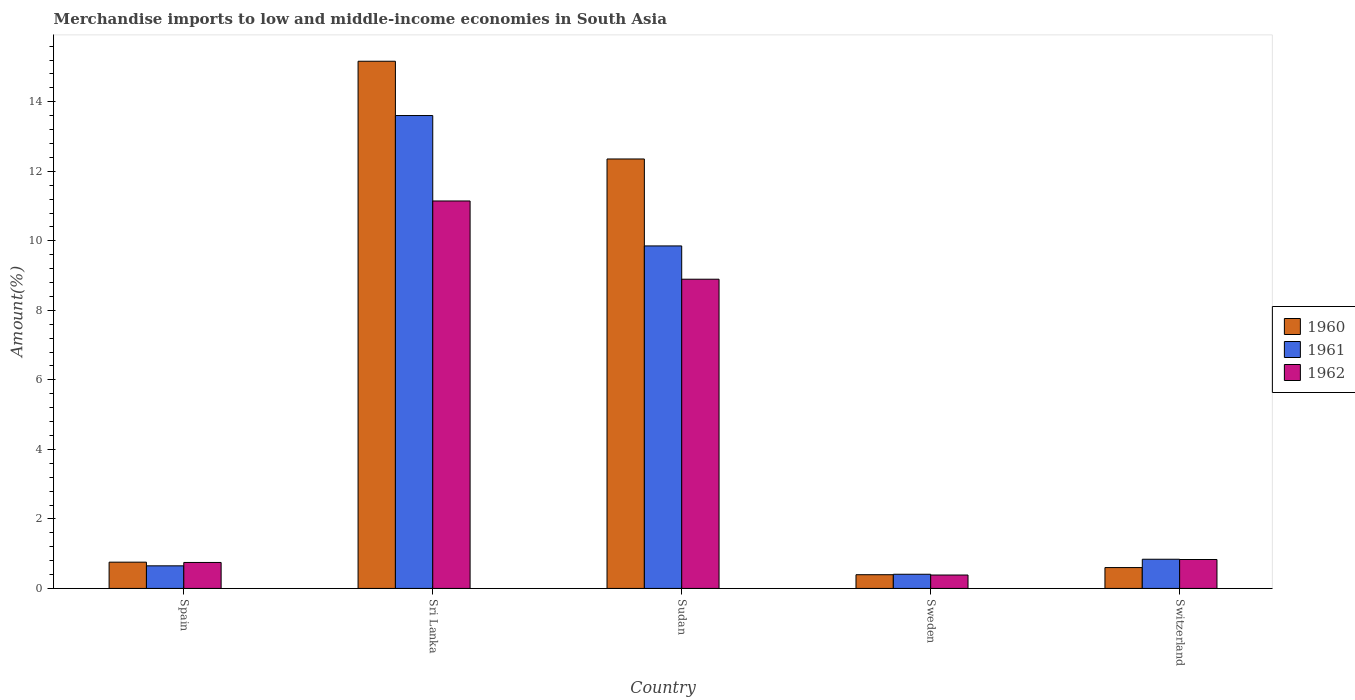How many different coloured bars are there?
Ensure brevity in your answer.  3. How many groups of bars are there?
Your response must be concise. 5. Are the number of bars on each tick of the X-axis equal?
Provide a short and direct response. Yes. How many bars are there on the 1st tick from the left?
Keep it short and to the point. 3. How many bars are there on the 4th tick from the right?
Provide a short and direct response. 3. What is the label of the 2nd group of bars from the left?
Your answer should be very brief. Sri Lanka. What is the percentage of amount earned from merchandise imports in 1962 in Spain?
Give a very brief answer. 0.75. Across all countries, what is the maximum percentage of amount earned from merchandise imports in 1962?
Offer a very short reply. 11.15. Across all countries, what is the minimum percentage of amount earned from merchandise imports in 1961?
Ensure brevity in your answer.  0.41. In which country was the percentage of amount earned from merchandise imports in 1961 maximum?
Your answer should be very brief. Sri Lanka. What is the total percentage of amount earned from merchandise imports in 1961 in the graph?
Offer a very short reply. 25.36. What is the difference between the percentage of amount earned from merchandise imports in 1961 in Sri Lanka and that in Sweden?
Offer a very short reply. 13.2. What is the difference between the percentage of amount earned from merchandise imports in 1960 in Spain and the percentage of amount earned from merchandise imports in 1962 in Sri Lanka?
Keep it short and to the point. -10.39. What is the average percentage of amount earned from merchandise imports in 1962 per country?
Ensure brevity in your answer.  4.4. What is the difference between the percentage of amount earned from merchandise imports of/in 1961 and percentage of amount earned from merchandise imports of/in 1960 in Sudan?
Provide a succinct answer. -2.5. What is the ratio of the percentage of amount earned from merchandise imports in 1962 in Spain to that in Switzerland?
Your answer should be very brief. 0.9. Is the percentage of amount earned from merchandise imports in 1961 in Spain less than that in Sudan?
Offer a very short reply. Yes. What is the difference between the highest and the second highest percentage of amount earned from merchandise imports in 1962?
Offer a very short reply. 8.06. What is the difference between the highest and the lowest percentage of amount earned from merchandise imports in 1961?
Your response must be concise. 13.2. In how many countries, is the percentage of amount earned from merchandise imports in 1961 greater than the average percentage of amount earned from merchandise imports in 1961 taken over all countries?
Your response must be concise. 2. Is the sum of the percentage of amount earned from merchandise imports in 1962 in Sudan and Sweden greater than the maximum percentage of amount earned from merchandise imports in 1960 across all countries?
Your response must be concise. No. What does the 2nd bar from the left in Sri Lanka represents?
Offer a very short reply. 1961. What does the 1st bar from the right in Sudan represents?
Make the answer very short. 1962. How many bars are there?
Make the answer very short. 15. Are the values on the major ticks of Y-axis written in scientific E-notation?
Provide a short and direct response. No. Does the graph contain any zero values?
Provide a succinct answer. No. Where does the legend appear in the graph?
Offer a very short reply. Center right. How many legend labels are there?
Your response must be concise. 3. How are the legend labels stacked?
Ensure brevity in your answer.  Vertical. What is the title of the graph?
Offer a very short reply. Merchandise imports to low and middle-income economies in South Asia. Does "2008" appear as one of the legend labels in the graph?
Provide a succinct answer. No. What is the label or title of the Y-axis?
Offer a terse response. Amount(%). What is the Amount(%) in 1960 in Spain?
Provide a short and direct response. 0.76. What is the Amount(%) in 1961 in Spain?
Provide a short and direct response. 0.65. What is the Amount(%) of 1962 in Spain?
Make the answer very short. 0.75. What is the Amount(%) of 1960 in Sri Lanka?
Offer a terse response. 15.17. What is the Amount(%) of 1961 in Sri Lanka?
Your response must be concise. 13.6. What is the Amount(%) of 1962 in Sri Lanka?
Ensure brevity in your answer.  11.15. What is the Amount(%) in 1960 in Sudan?
Give a very brief answer. 12.35. What is the Amount(%) in 1961 in Sudan?
Offer a very short reply. 9.85. What is the Amount(%) in 1962 in Sudan?
Your answer should be compact. 8.9. What is the Amount(%) in 1960 in Sweden?
Offer a very short reply. 0.39. What is the Amount(%) of 1961 in Sweden?
Offer a very short reply. 0.41. What is the Amount(%) in 1962 in Sweden?
Offer a terse response. 0.39. What is the Amount(%) of 1960 in Switzerland?
Your response must be concise. 0.6. What is the Amount(%) in 1961 in Switzerland?
Provide a short and direct response. 0.84. What is the Amount(%) of 1962 in Switzerland?
Provide a succinct answer. 0.83. Across all countries, what is the maximum Amount(%) in 1960?
Your response must be concise. 15.17. Across all countries, what is the maximum Amount(%) of 1961?
Ensure brevity in your answer.  13.6. Across all countries, what is the maximum Amount(%) of 1962?
Offer a very short reply. 11.15. Across all countries, what is the minimum Amount(%) of 1960?
Keep it short and to the point. 0.39. Across all countries, what is the minimum Amount(%) in 1961?
Provide a short and direct response. 0.41. Across all countries, what is the minimum Amount(%) in 1962?
Keep it short and to the point. 0.39. What is the total Amount(%) of 1960 in the graph?
Provide a succinct answer. 29.27. What is the total Amount(%) of 1961 in the graph?
Offer a terse response. 25.36. What is the total Amount(%) of 1962 in the graph?
Give a very brief answer. 22.01. What is the difference between the Amount(%) in 1960 in Spain and that in Sri Lanka?
Offer a terse response. -14.41. What is the difference between the Amount(%) of 1961 in Spain and that in Sri Lanka?
Your response must be concise. -12.95. What is the difference between the Amount(%) of 1962 in Spain and that in Sri Lanka?
Offer a terse response. -10.4. What is the difference between the Amount(%) in 1960 in Spain and that in Sudan?
Provide a short and direct response. -11.6. What is the difference between the Amount(%) of 1961 in Spain and that in Sudan?
Give a very brief answer. -9.2. What is the difference between the Amount(%) in 1962 in Spain and that in Sudan?
Provide a succinct answer. -8.15. What is the difference between the Amount(%) in 1960 in Spain and that in Sweden?
Your response must be concise. 0.36. What is the difference between the Amount(%) of 1961 in Spain and that in Sweden?
Provide a succinct answer. 0.24. What is the difference between the Amount(%) of 1962 in Spain and that in Sweden?
Make the answer very short. 0.36. What is the difference between the Amount(%) of 1960 in Spain and that in Switzerland?
Ensure brevity in your answer.  0.16. What is the difference between the Amount(%) in 1961 in Spain and that in Switzerland?
Your response must be concise. -0.19. What is the difference between the Amount(%) in 1962 in Spain and that in Switzerland?
Provide a short and direct response. -0.09. What is the difference between the Amount(%) of 1960 in Sri Lanka and that in Sudan?
Give a very brief answer. 2.81. What is the difference between the Amount(%) in 1961 in Sri Lanka and that in Sudan?
Keep it short and to the point. 3.75. What is the difference between the Amount(%) in 1962 in Sri Lanka and that in Sudan?
Your response must be concise. 2.25. What is the difference between the Amount(%) in 1960 in Sri Lanka and that in Sweden?
Offer a very short reply. 14.77. What is the difference between the Amount(%) in 1961 in Sri Lanka and that in Sweden?
Offer a terse response. 13.2. What is the difference between the Amount(%) in 1962 in Sri Lanka and that in Sweden?
Your response must be concise. 10.76. What is the difference between the Amount(%) in 1960 in Sri Lanka and that in Switzerland?
Your response must be concise. 14.57. What is the difference between the Amount(%) in 1961 in Sri Lanka and that in Switzerland?
Make the answer very short. 12.76. What is the difference between the Amount(%) in 1962 in Sri Lanka and that in Switzerland?
Offer a very short reply. 10.31. What is the difference between the Amount(%) of 1960 in Sudan and that in Sweden?
Provide a short and direct response. 11.96. What is the difference between the Amount(%) of 1961 in Sudan and that in Sweden?
Ensure brevity in your answer.  9.45. What is the difference between the Amount(%) of 1962 in Sudan and that in Sweden?
Provide a short and direct response. 8.51. What is the difference between the Amount(%) of 1960 in Sudan and that in Switzerland?
Provide a short and direct response. 11.75. What is the difference between the Amount(%) of 1961 in Sudan and that in Switzerland?
Offer a very short reply. 9.01. What is the difference between the Amount(%) of 1962 in Sudan and that in Switzerland?
Provide a short and direct response. 8.06. What is the difference between the Amount(%) of 1960 in Sweden and that in Switzerland?
Give a very brief answer. -0.2. What is the difference between the Amount(%) of 1961 in Sweden and that in Switzerland?
Your response must be concise. -0.43. What is the difference between the Amount(%) of 1962 in Sweden and that in Switzerland?
Keep it short and to the point. -0.45. What is the difference between the Amount(%) in 1960 in Spain and the Amount(%) in 1961 in Sri Lanka?
Provide a succinct answer. -12.85. What is the difference between the Amount(%) of 1960 in Spain and the Amount(%) of 1962 in Sri Lanka?
Make the answer very short. -10.39. What is the difference between the Amount(%) in 1961 in Spain and the Amount(%) in 1962 in Sri Lanka?
Your answer should be very brief. -10.5. What is the difference between the Amount(%) of 1960 in Spain and the Amount(%) of 1961 in Sudan?
Ensure brevity in your answer.  -9.1. What is the difference between the Amount(%) of 1960 in Spain and the Amount(%) of 1962 in Sudan?
Your answer should be compact. -8.14. What is the difference between the Amount(%) in 1961 in Spain and the Amount(%) in 1962 in Sudan?
Offer a very short reply. -8.25. What is the difference between the Amount(%) of 1960 in Spain and the Amount(%) of 1961 in Sweden?
Ensure brevity in your answer.  0.35. What is the difference between the Amount(%) in 1960 in Spain and the Amount(%) in 1962 in Sweden?
Give a very brief answer. 0.37. What is the difference between the Amount(%) in 1961 in Spain and the Amount(%) in 1962 in Sweden?
Ensure brevity in your answer.  0.26. What is the difference between the Amount(%) in 1960 in Spain and the Amount(%) in 1961 in Switzerland?
Your answer should be very brief. -0.08. What is the difference between the Amount(%) in 1960 in Spain and the Amount(%) in 1962 in Switzerland?
Offer a very short reply. -0.08. What is the difference between the Amount(%) in 1961 in Spain and the Amount(%) in 1962 in Switzerland?
Offer a terse response. -0.18. What is the difference between the Amount(%) of 1960 in Sri Lanka and the Amount(%) of 1961 in Sudan?
Provide a succinct answer. 5.31. What is the difference between the Amount(%) in 1960 in Sri Lanka and the Amount(%) in 1962 in Sudan?
Give a very brief answer. 6.27. What is the difference between the Amount(%) of 1961 in Sri Lanka and the Amount(%) of 1962 in Sudan?
Your answer should be compact. 4.71. What is the difference between the Amount(%) of 1960 in Sri Lanka and the Amount(%) of 1961 in Sweden?
Offer a terse response. 14.76. What is the difference between the Amount(%) in 1960 in Sri Lanka and the Amount(%) in 1962 in Sweden?
Offer a very short reply. 14.78. What is the difference between the Amount(%) in 1961 in Sri Lanka and the Amount(%) in 1962 in Sweden?
Give a very brief answer. 13.22. What is the difference between the Amount(%) of 1960 in Sri Lanka and the Amount(%) of 1961 in Switzerland?
Offer a very short reply. 14.33. What is the difference between the Amount(%) in 1960 in Sri Lanka and the Amount(%) in 1962 in Switzerland?
Give a very brief answer. 14.33. What is the difference between the Amount(%) in 1961 in Sri Lanka and the Amount(%) in 1962 in Switzerland?
Give a very brief answer. 12.77. What is the difference between the Amount(%) of 1960 in Sudan and the Amount(%) of 1961 in Sweden?
Provide a succinct answer. 11.95. What is the difference between the Amount(%) in 1960 in Sudan and the Amount(%) in 1962 in Sweden?
Ensure brevity in your answer.  11.97. What is the difference between the Amount(%) of 1961 in Sudan and the Amount(%) of 1962 in Sweden?
Your answer should be very brief. 9.47. What is the difference between the Amount(%) in 1960 in Sudan and the Amount(%) in 1961 in Switzerland?
Offer a terse response. 11.51. What is the difference between the Amount(%) in 1960 in Sudan and the Amount(%) in 1962 in Switzerland?
Provide a short and direct response. 11.52. What is the difference between the Amount(%) in 1961 in Sudan and the Amount(%) in 1962 in Switzerland?
Make the answer very short. 9.02. What is the difference between the Amount(%) of 1960 in Sweden and the Amount(%) of 1961 in Switzerland?
Your answer should be compact. -0.44. What is the difference between the Amount(%) in 1960 in Sweden and the Amount(%) in 1962 in Switzerland?
Make the answer very short. -0.44. What is the difference between the Amount(%) of 1961 in Sweden and the Amount(%) of 1962 in Switzerland?
Keep it short and to the point. -0.42. What is the average Amount(%) of 1960 per country?
Keep it short and to the point. 5.85. What is the average Amount(%) in 1961 per country?
Offer a terse response. 5.07. What is the average Amount(%) in 1962 per country?
Give a very brief answer. 4.4. What is the difference between the Amount(%) of 1960 and Amount(%) of 1961 in Spain?
Your response must be concise. 0.11. What is the difference between the Amount(%) in 1960 and Amount(%) in 1962 in Spain?
Your response must be concise. 0.01. What is the difference between the Amount(%) in 1961 and Amount(%) in 1962 in Spain?
Your response must be concise. -0.1. What is the difference between the Amount(%) of 1960 and Amount(%) of 1961 in Sri Lanka?
Provide a succinct answer. 1.56. What is the difference between the Amount(%) in 1960 and Amount(%) in 1962 in Sri Lanka?
Provide a short and direct response. 4.02. What is the difference between the Amount(%) in 1961 and Amount(%) in 1962 in Sri Lanka?
Ensure brevity in your answer.  2.46. What is the difference between the Amount(%) of 1960 and Amount(%) of 1961 in Sudan?
Provide a short and direct response. 2.5. What is the difference between the Amount(%) in 1960 and Amount(%) in 1962 in Sudan?
Your answer should be very brief. 3.46. What is the difference between the Amount(%) in 1961 and Amount(%) in 1962 in Sudan?
Offer a very short reply. 0.96. What is the difference between the Amount(%) in 1960 and Amount(%) in 1961 in Sweden?
Offer a very short reply. -0.01. What is the difference between the Amount(%) in 1960 and Amount(%) in 1962 in Sweden?
Ensure brevity in your answer.  0.01. What is the difference between the Amount(%) of 1961 and Amount(%) of 1962 in Sweden?
Provide a short and direct response. 0.02. What is the difference between the Amount(%) in 1960 and Amount(%) in 1961 in Switzerland?
Make the answer very short. -0.24. What is the difference between the Amount(%) of 1960 and Amount(%) of 1962 in Switzerland?
Your answer should be compact. -0.23. What is the difference between the Amount(%) of 1961 and Amount(%) of 1962 in Switzerland?
Make the answer very short. 0.01. What is the ratio of the Amount(%) in 1960 in Spain to that in Sri Lanka?
Your answer should be compact. 0.05. What is the ratio of the Amount(%) in 1961 in Spain to that in Sri Lanka?
Offer a terse response. 0.05. What is the ratio of the Amount(%) in 1962 in Spain to that in Sri Lanka?
Ensure brevity in your answer.  0.07. What is the ratio of the Amount(%) in 1960 in Spain to that in Sudan?
Ensure brevity in your answer.  0.06. What is the ratio of the Amount(%) of 1961 in Spain to that in Sudan?
Your answer should be compact. 0.07. What is the ratio of the Amount(%) in 1962 in Spain to that in Sudan?
Ensure brevity in your answer.  0.08. What is the ratio of the Amount(%) of 1960 in Spain to that in Sweden?
Give a very brief answer. 1.91. What is the ratio of the Amount(%) of 1961 in Spain to that in Sweden?
Your answer should be compact. 1.59. What is the ratio of the Amount(%) in 1962 in Spain to that in Sweden?
Ensure brevity in your answer.  1.94. What is the ratio of the Amount(%) of 1960 in Spain to that in Switzerland?
Keep it short and to the point. 1.26. What is the ratio of the Amount(%) in 1961 in Spain to that in Switzerland?
Offer a terse response. 0.77. What is the ratio of the Amount(%) in 1962 in Spain to that in Switzerland?
Offer a terse response. 0.9. What is the ratio of the Amount(%) of 1960 in Sri Lanka to that in Sudan?
Your answer should be very brief. 1.23. What is the ratio of the Amount(%) in 1961 in Sri Lanka to that in Sudan?
Provide a succinct answer. 1.38. What is the ratio of the Amount(%) in 1962 in Sri Lanka to that in Sudan?
Your answer should be compact. 1.25. What is the ratio of the Amount(%) of 1960 in Sri Lanka to that in Sweden?
Ensure brevity in your answer.  38.4. What is the ratio of the Amount(%) in 1961 in Sri Lanka to that in Sweden?
Offer a very short reply. 33.37. What is the ratio of the Amount(%) in 1962 in Sri Lanka to that in Sweden?
Offer a very short reply. 28.89. What is the ratio of the Amount(%) in 1960 in Sri Lanka to that in Switzerland?
Ensure brevity in your answer.  25.28. What is the ratio of the Amount(%) in 1961 in Sri Lanka to that in Switzerland?
Provide a short and direct response. 16.2. What is the ratio of the Amount(%) in 1962 in Sri Lanka to that in Switzerland?
Your answer should be compact. 13.39. What is the ratio of the Amount(%) of 1960 in Sudan to that in Sweden?
Offer a terse response. 31.28. What is the ratio of the Amount(%) in 1961 in Sudan to that in Sweden?
Provide a succinct answer. 24.17. What is the ratio of the Amount(%) of 1962 in Sudan to that in Sweden?
Offer a very short reply. 23.06. What is the ratio of the Amount(%) of 1960 in Sudan to that in Switzerland?
Your answer should be compact. 20.59. What is the ratio of the Amount(%) of 1961 in Sudan to that in Switzerland?
Your answer should be compact. 11.73. What is the ratio of the Amount(%) in 1962 in Sudan to that in Switzerland?
Ensure brevity in your answer.  10.69. What is the ratio of the Amount(%) of 1960 in Sweden to that in Switzerland?
Your answer should be very brief. 0.66. What is the ratio of the Amount(%) in 1961 in Sweden to that in Switzerland?
Provide a short and direct response. 0.49. What is the ratio of the Amount(%) of 1962 in Sweden to that in Switzerland?
Ensure brevity in your answer.  0.46. What is the difference between the highest and the second highest Amount(%) of 1960?
Make the answer very short. 2.81. What is the difference between the highest and the second highest Amount(%) in 1961?
Make the answer very short. 3.75. What is the difference between the highest and the second highest Amount(%) in 1962?
Ensure brevity in your answer.  2.25. What is the difference between the highest and the lowest Amount(%) of 1960?
Keep it short and to the point. 14.77. What is the difference between the highest and the lowest Amount(%) of 1961?
Offer a very short reply. 13.2. What is the difference between the highest and the lowest Amount(%) in 1962?
Offer a very short reply. 10.76. 